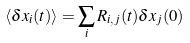<formula> <loc_0><loc_0><loc_500><loc_500>\langle \delta x _ { i } ( t ) \rangle = \sum _ { i } R _ { i , j } ( t ) \delta x _ { j } ( 0 )</formula> 